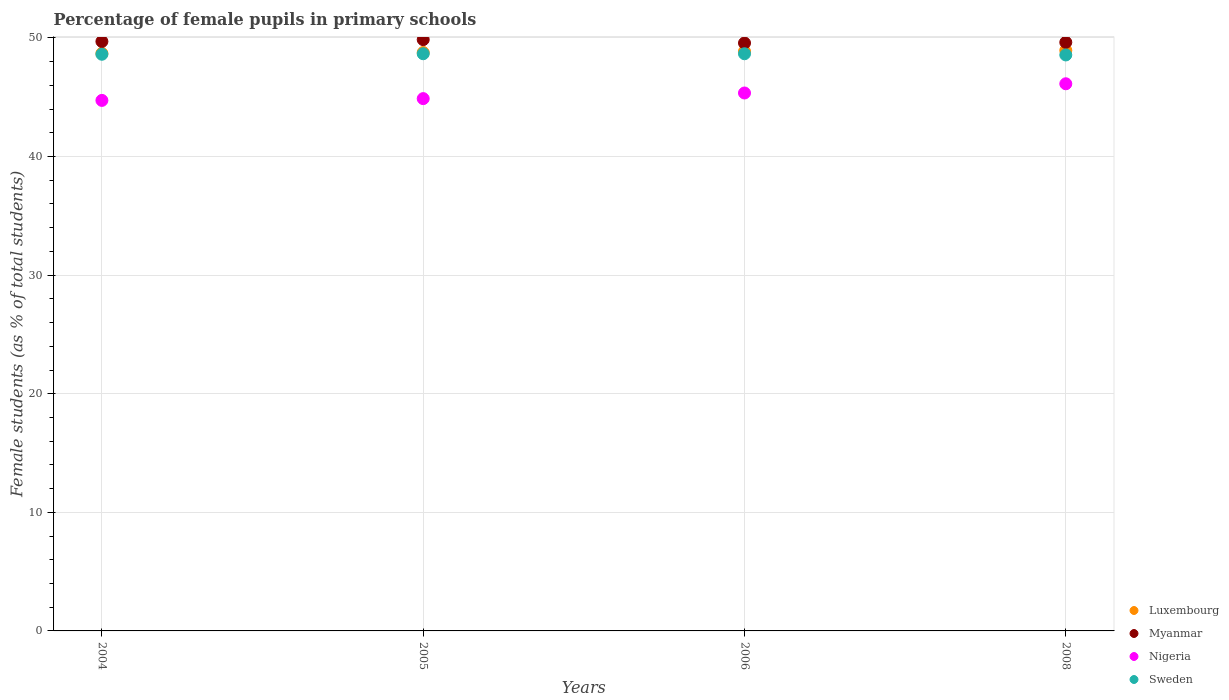Is the number of dotlines equal to the number of legend labels?
Offer a terse response. Yes. What is the percentage of female pupils in primary schools in Myanmar in 2008?
Offer a terse response. 49.63. Across all years, what is the maximum percentage of female pupils in primary schools in Luxembourg?
Keep it short and to the point. 48.95. Across all years, what is the minimum percentage of female pupils in primary schools in Nigeria?
Give a very brief answer. 44.73. In which year was the percentage of female pupils in primary schools in Myanmar maximum?
Provide a short and direct response. 2005. In which year was the percentage of female pupils in primary schools in Nigeria minimum?
Your answer should be compact. 2004. What is the total percentage of female pupils in primary schools in Luxembourg in the graph?
Offer a terse response. 195.29. What is the difference between the percentage of female pupils in primary schools in Luxembourg in 2005 and that in 2006?
Provide a succinct answer. -0.09. What is the difference between the percentage of female pupils in primary schools in Luxembourg in 2006 and the percentage of female pupils in primary schools in Myanmar in 2005?
Your answer should be compact. -0.99. What is the average percentage of female pupils in primary schools in Nigeria per year?
Make the answer very short. 45.28. In the year 2004, what is the difference between the percentage of female pupils in primary schools in Myanmar and percentage of female pupils in primary schools in Sweden?
Ensure brevity in your answer.  1.08. What is the ratio of the percentage of female pupils in primary schools in Sweden in 2006 to that in 2008?
Your answer should be very brief. 1. What is the difference between the highest and the second highest percentage of female pupils in primary schools in Nigeria?
Ensure brevity in your answer.  0.78. What is the difference between the highest and the lowest percentage of female pupils in primary schools in Nigeria?
Keep it short and to the point. 1.4. In how many years, is the percentage of female pupils in primary schools in Sweden greater than the average percentage of female pupils in primary schools in Sweden taken over all years?
Your answer should be very brief. 2. Is the sum of the percentage of female pupils in primary schools in Luxembourg in 2006 and 2008 greater than the maximum percentage of female pupils in primary schools in Myanmar across all years?
Your answer should be very brief. Yes. Is it the case that in every year, the sum of the percentage of female pupils in primary schools in Nigeria and percentage of female pupils in primary schools in Sweden  is greater than the percentage of female pupils in primary schools in Luxembourg?
Provide a succinct answer. Yes. Does the percentage of female pupils in primary schools in Myanmar monotonically increase over the years?
Make the answer very short. No. Is the percentage of female pupils in primary schools in Myanmar strictly greater than the percentage of female pupils in primary schools in Sweden over the years?
Provide a short and direct response. Yes. How many dotlines are there?
Keep it short and to the point. 4. Are the values on the major ticks of Y-axis written in scientific E-notation?
Make the answer very short. No. Does the graph contain any zero values?
Give a very brief answer. No. Does the graph contain grids?
Keep it short and to the point. Yes. What is the title of the graph?
Your response must be concise. Percentage of female pupils in primary schools. What is the label or title of the X-axis?
Keep it short and to the point. Years. What is the label or title of the Y-axis?
Ensure brevity in your answer.  Female students (as % of total students). What is the Female students (as % of total students) of Luxembourg in 2004?
Your answer should be compact. 48.7. What is the Female students (as % of total students) of Myanmar in 2004?
Provide a succinct answer. 49.7. What is the Female students (as % of total students) in Nigeria in 2004?
Offer a very short reply. 44.73. What is the Female students (as % of total students) of Sweden in 2004?
Offer a terse response. 48.63. What is the Female students (as % of total students) of Luxembourg in 2005?
Your response must be concise. 48.77. What is the Female students (as % of total students) of Myanmar in 2005?
Offer a terse response. 49.86. What is the Female students (as % of total students) in Nigeria in 2005?
Make the answer very short. 44.88. What is the Female students (as % of total students) of Sweden in 2005?
Provide a short and direct response. 48.67. What is the Female students (as % of total students) of Luxembourg in 2006?
Keep it short and to the point. 48.87. What is the Female students (as % of total students) of Myanmar in 2006?
Provide a succinct answer. 49.57. What is the Female students (as % of total students) of Nigeria in 2006?
Provide a short and direct response. 45.36. What is the Female students (as % of total students) of Sweden in 2006?
Offer a very short reply. 48.67. What is the Female students (as % of total students) in Luxembourg in 2008?
Provide a succinct answer. 48.95. What is the Female students (as % of total students) in Myanmar in 2008?
Provide a succinct answer. 49.63. What is the Female students (as % of total students) of Nigeria in 2008?
Your answer should be compact. 46.14. What is the Female students (as % of total students) in Sweden in 2008?
Ensure brevity in your answer.  48.57. Across all years, what is the maximum Female students (as % of total students) of Luxembourg?
Ensure brevity in your answer.  48.95. Across all years, what is the maximum Female students (as % of total students) of Myanmar?
Your answer should be compact. 49.86. Across all years, what is the maximum Female students (as % of total students) in Nigeria?
Keep it short and to the point. 46.14. Across all years, what is the maximum Female students (as % of total students) of Sweden?
Keep it short and to the point. 48.67. Across all years, what is the minimum Female students (as % of total students) in Luxembourg?
Make the answer very short. 48.7. Across all years, what is the minimum Female students (as % of total students) in Myanmar?
Offer a very short reply. 49.57. Across all years, what is the minimum Female students (as % of total students) of Nigeria?
Make the answer very short. 44.73. Across all years, what is the minimum Female students (as % of total students) in Sweden?
Give a very brief answer. 48.57. What is the total Female students (as % of total students) in Luxembourg in the graph?
Offer a very short reply. 195.29. What is the total Female students (as % of total students) in Myanmar in the graph?
Offer a terse response. 198.76. What is the total Female students (as % of total students) in Nigeria in the graph?
Make the answer very short. 181.11. What is the total Female students (as % of total students) in Sweden in the graph?
Keep it short and to the point. 194.53. What is the difference between the Female students (as % of total students) in Luxembourg in 2004 and that in 2005?
Provide a short and direct response. -0.07. What is the difference between the Female students (as % of total students) in Myanmar in 2004 and that in 2005?
Keep it short and to the point. -0.16. What is the difference between the Female students (as % of total students) in Nigeria in 2004 and that in 2005?
Keep it short and to the point. -0.15. What is the difference between the Female students (as % of total students) in Sweden in 2004 and that in 2005?
Make the answer very short. -0.04. What is the difference between the Female students (as % of total students) in Luxembourg in 2004 and that in 2006?
Give a very brief answer. -0.17. What is the difference between the Female students (as % of total students) in Myanmar in 2004 and that in 2006?
Your response must be concise. 0.13. What is the difference between the Female students (as % of total students) of Nigeria in 2004 and that in 2006?
Provide a short and direct response. -0.62. What is the difference between the Female students (as % of total students) in Sweden in 2004 and that in 2006?
Provide a succinct answer. -0.04. What is the difference between the Female students (as % of total students) of Luxembourg in 2004 and that in 2008?
Offer a very short reply. -0.26. What is the difference between the Female students (as % of total students) of Myanmar in 2004 and that in 2008?
Offer a terse response. 0.07. What is the difference between the Female students (as % of total students) of Nigeria in 2004 and that in 2008?
Ensure brevity in your answer.  -1.4. What is the difference between the Female students (as % of total students) of Sweden in 2004 and that in 2008?
Ensure brevity in your answer.  0.06. What is the difference between the Female students (as % of total students) of Luxembourg in 2005 and that in 2006?
Your answer should be very brief. -0.09. What is the difference between the Female students (as % of total students) in Myanmar in 2005 and that in 2006?
Provide a succinct answer. 0.29. What is the difference between the Female students (as % of total students) in Nigeria in 2005 and that in 2006?
Provide a succinct answer. -0.47. What is the difference between the Female students (as % of total students) of Sweden in 2005 and that in 2006?
Make the answer very short. 0. What is the difference between the Female students (as % of total students) in Luxembourg in 2005 and that in 2008?
Give a very brief answer. -0.18. What is the difference between the Female students (as % of total students) in Myanmar in 2005 and that in 2008?
Offer a terse response. 0.23. What is the difference between the Female students (as % of total students) of Nigeria in 2005 and that in 2008?
Your response must be concise. -1.25. What is the difference between the Female students (as % of total students) in Sweden in 2005 and that in 2008?
Offer a very short reply. 0.1. What is the difference between the Female students (as % of total students) of Luxembourg in 2006 and that in 2008?
Give a very brief answer. -0.09. What is the difference between the Female students (as % of total students) in Myanmar in 2006 and that in 2008?
Offer a terse response. -0.06. What is the difference between the Female students (as % of total students) in Nigeria in 2006 and that in 2008?
Your answer should be compact. -0.78. What is the difference between the Female students (as % of total students) of Sweden in 2006 and that in 2008?
Provide a short and direct response. 0.1. What is the difference between the Female students (as % of total students) of Luxembourg in 2004 and the Female students (as % of total students) of Myanmar in 2005?
Keep it short and to the point. -1.16. What is the difference between the Female students (as % of total students) in Luxembourg in 2004 and the Female students (as % of total students) in Nigeria in 2005?
Give a very brief answer. 3.81. What is the difference between the Female students (as % of total students) of Luxembourg in 2004 and the Female students (as % of total students) of Sweden in 2005?
Your answer should be very brief. 0.03. What is the difference between the Female students (as % of total students) of Myanmar in 2004 and the Female students (as % of total students) of Nigeria in 2005?
Your response must be concise. 4.82. What is the difference between the Female students (as % of total students) in Myanmar in 2004 and the Female students (as % of total students) in Sweden in 2005?
Provide a short and direct response. 1.03. What is the difference between the Female students (as % of total students) in Nigeria in 2004 and the Female students (as % of total students) in Sweden in 2005?
Keep it short and to the point. -3.94. What is the difference between the Female students (as % of total students) of Luxembourg in 2004 and the Female students (as % of total students) of Myanmar in 2006?
Give a very brief answer. -0.87. What is the difference between the Female students (as % of total students) of Luxembourg in 2004 and the Female students (as % of total students) of Nigeria in 2006?
Your response must be concise. 3.34. What is the difference between the Female students (as % of total students) of Luxembourg in 2004 and the Female students (as % of total students) of Sweden in 2006?
Ensure brevity in your answer.  0.03. What is the difference between the Female students (as % of total students) in Myanmar in 2004 and the Female students (as % of total students) in Nigeria in 2006?
Your response must be concise. 4.34. What is the difference between the Female students (as % of total students) of Myanmar in 2004 and the Female students (as % of total students) of Sweden in 2006?
Give a very brief answer. 1.04. What is the difference between the Female students (as % of total students) of Nigeria in 2004 and the Female students (as % of total students) of Sweden in 2006?
Offer a very short reply. -3.93. What is the difference between the Female students (as % of total students) of Luxembourg in 2004 and the Female students (as % of total students) of Myanmar in 2008?
Give a very brief answer. -0.93. What is the difference between the Female students (as % of total students) of Luxembourg in 2004 and the Female students (as % of total students) of Nigeria in 2008?
Offer a very short reply. 2.56. What is the difference between the Female students (as % of total students) in Luxembourg in 2004 and the Female students (as % of total students) in Sweden in 2008?
Provide a succinct answer. 0.13. What is the difference between the Female students (as % of total students) in Myanmar in 2004 and the Female students (as % of total students) in Nigeria in 2008?
Your answer should be very brief. 3.57. What is the difference between the Female students (as % of total students) of Myanmar in 2004 and the Female students (as % of total students) of Sweden in 2008?
Provide a short and direct response. 1.14. What is the difference between the Female students (as % of total students) in Nigeria in 2004 and the Female students (as % of total students) in Sweden in 2008?
Your response must be concise. -3.83. What is the difference between the Female students (as % of total students) of Luxembourg in 2005 and the Female students (as % of total students) of Myanmar in 2006?
Offer a very short reply. -0.8. What is the difference between the Female students (as % of total students) of Luxembourg in 2005 and the Female students (as % of total students) of Nigeria in 2006?
Offer a very short reply. 3.41. What is the difference between the Female students (as % of total students) of Luxembourg in 2005 and the Female students (as % of total students) of Sweden in 2006?
Make the answer very short. 0.1. What is the difference between the Female students (as % of total students) of Myanmar in 2005 and the Female students (as % of total students) of Nigeria in 2006?
Your answer should be very brief. 4.5. What is the difference between the Female students (as % of total students) in Myanmar in 2005 and the Female students (as % of total students) in Sweden in 2006?
Provide a short and direct response. 1.19. What is the difference between the Female students (as % of total students) of Nigeria in 2005 and the Female students (as % of total students) of Sweden in 2006?
Ensure brevity in your answer.  -3.78. What is the difference between the Female students (as % of total students) of Luxembourg in 2005 and the Female students (as % of total students) of Myanmar in 2008?
Provide a short and direct response. -0.86. What is the difference between the Female students (as % of total students) of Luxembourg in 2005 and the Female students (as % of total students) of Nigeria in 2008?
Your response must be concise. 2.64. What is the difference between the Female students (as % of total students) in Luxembourg in 2005 and the Female students (as % of total students) in Sweden in 2008?
Give a very brief answer. 0.21. What is the difference between the Female students (as % of total students) of Myanmar in 2005 and the Female students (as % of total students) of Nigeria in 2008?
Keep it short and to the point. 3.72. What is the difference between the Female students (as % of total students) in Myanmar in 2005 and the Female students (as % of total students) in Sweden in 2008?
Offer a very short reply. 1.29. What is the difference between the Female students (as % of total students) of Nigeria in 2005 and the Female students (as % of total students) of Sweden in 2008?
Your answer should be very brief. -3.68. What is the difference between the Female students (as % of total students) in Luxembourg in 2006 and the Female students (as % of total students) in Myanmar in 2008?
Give a very brief answer. -0.76. What is the difference between the Female students (as % of total students) of Luxembourg in 2006 and the Female students (as % of total students) of Nigeria in 2008?
Provide a short and direct response. 2.73. What is the difference between the Female students (as % of total students) of Luxembourg in 2006 and the Female students (as % of total students) of Sweden in 2008?
Offer a very short reply. 0.3. What is the difference between the Female students (as % of total students) in Myanmar in 2006 and the Female students (as % of total students) in Nigeria in 2008?
Provide a succinct answer. 3.44. What is the difference between the Female students (as % of total students) of Myanmar in 2006 and the Female students (as % of total students) of Sweden in 2008?
Your answer should be very brief. 1.01. What is the difference between the Female students (as % of total students) in Nigeria in 2006 and the Female students (as % of total students) in Sweden in 2008?
Give a very brief answer. -3.21. What is the average Female students (as % of total students) in Luxembourg per year?
Keep it short and to the point. 48.82. What is the average Female students (as % of total students) of Myanmar per year?
Provide a short and direct response. 49.69. What is the average Female students (as % of total students) of Nigeria per year?
Offer a very short reply. 45.28. What is the average Female students (as % of total students) of Sweden per year?
Provide a short and direct response. 48.63. In the year 2004, what is the difference between the Female students (as % of total students) of Luxembourg and Female students (as % of total students) of Myanmar?
Provide a short and direct response. -1. In the year 2004, what is the difference between the Female students (as % of total students) in Luxembourg and Female students (as % of total students) in Nigeria?
Provide a succinct answer. 3.96. In the year 2004, what is the difference between the Female students (as % of total students) in Luxembourg and Female students (as % of total students) in Sweden?
Provide a short and direct response. 0.07. In the year 2004, what is the difference between the Female students (as % of total students) of Myanmar and Female students (as % of total students) of Nigeria?
Offer a terse response. 4.97. In the year 2004, what is the difference between the Female students (as % of total students) in Myanmar and Female students (as % of total students) in Sweden?
Keep it short and to the point. 1.08. In the year 2004, what is the difference between the Female students (as % of total students) of Nigeria and Female students (as % of total students) of Sweden?
Ensure brevity in your answer.  -3.89. In the year 2005, what is the difference between the Female students (as % of total students) in Luxembourg and Female students (as % of total students) in Myanmar?
Give a very brief answer. -1.09. In the year 2005, what is the difference between the Female students (as % of total students) in Luxembourg and Female students (as % of total students) in Nigeria?
Give a very brief answer. 3.89. In the year 2005, what is the difference between the Female students (as % of total students) of Luxembourg and Female students (as % of total students) of Sweden?
Offer a very short reply. 0.1. In the year 2005, what is the difference between the Female students (as % of total students) in Myanmar and Female students (as % of total students) in Nigeria?
Ensure brevity in your answer.  4.98. In the year 2005, what is the difference between the Female students (as % of total students) in Myanmar and Female students (as % of total students) in Sweden?
Offer a terse response. 1.19. In the year 2005, what is the difference between the Female students (as % of total students) in Nigeria and Female students (as % of total students) in Sweden?
Provide a succinct answer. -3.78. In the year 2006, what is the difference between the Female students (as % of total students) in Luxembourg and Female students (as % of total students) in Myanmar?
Your response must be concise. -0.71. In the year 2006, what is the difference between the Female students (as % of total students) in Luxembourg and Female students (as % of total students) in Nigeria?
Your answer should be compact. 3.51. In the year 2006, what is the difference between the Female students (as % of total students) in Luxembourg and Female students (as % of total students) in Sweden?
Ensure brevity in your answer.  0.2. In the year 2006, what is the difference between the Female students (as % of total students) of Myanmar and Female students (as % of total students) of Nigeria?
Offer a terse response. 4.21. In the year 2006, what is the difference between the Female students (as % of total students) of Myanmar and Female students (as % of total students) of Sweden?
Your answer should be very brief. 0.91. In the year 2006, what is the difference between the Female students (as % of total students) in Nigeria and Female students (as % of total students) in Sweden?
Ensure brevity in your answer.  -3.31. In the year 2008, what is the difference between the Female students (as % of total students) in Luxembourg and Female students (as % of total students) in Myanmar?
Offer a very short reply. -0.68. In the year 2008, what is the difference between the Female students (as % of total students) of Luxembourg and Female students (as % of total students) of Nigeria?
Provide a succinct answer. 2.82. In the year 2008, what is the difference between the Female students (as % of total students) of Luxembourg and Female students (as % of total students) of Sweden?
Keep it short and to the point. 0.39. In the year 2008, what is the difference between the Female students (as % of total students) of Myanmar and Female students (as % of total students) of Nigeria?
Your answer should be compact. 3.49. In the year 2008, what is the difference between the Female students (as % of total students) of Myanmar and Female students (as % of total students) of Sweden?
Make the answer very short. 1.06. In the year 2008, what is the difference between the Female students (as % of total students) in Nigeria and Female students (as % of total students) in Sweden?
Your answer should be compact. -2.43. What is the ratio of the Female students (as % of total students) of Sweden in 2004 to that in 2005?
Make the answer very short. 1. What is the ratio of the Female students (as % of total students) of Nigeria in 2004 to that in 2006?
Ensure brevity in your answer.  0.99. What is the ratio of the Female students (as % of total students) of Luxembourg in 2004 to that in 2008?
Your answer should be compact. 0.99. What is the ratio of the Female students (as % of total students) in Myanmar in 2004 to that in 2008?
Provide a succinct answer. 1. What is the ratio of the Female students (as % of total students) in Nigeria in 2004 to that in 2008?
Offer a very short reply. 0.97. What is the ratio of the Female students (as % of total students) of Luxembourg in 2005 to that in 2006?
Your response must be concise. 1. What is the ratio of the Female students (as % of total students) in Nigeria in 2005 to that in 2006?
Keep it short and to the point. 0.99. What is the ratio of the Female students (as % of total students) in Sweden in 2005 to that in 2006?
Make the answer very short. 1. What is the ratio of the Female students (as % of total students) of Luxembourg in 2005 to that in 2008?
Your response must be concise. 1. What is the ratio of the Female students (as % of total students) in Myanmar in 2005 to that in 2008?
Give a very brief answer. 1. What is the ratio of the Female students (as % of total students) of Nigeria in 2005 to that in 2008?
Keep it short and to the point. 0.97. What is the ratio of the Female students (as % of total students) of Sweden in 2005 to that in 2008?
Your answer should be compact. 1. What is the ratio of the Female students (as % of total students) in Luxembourg in 2006 to that in 2008?
Your response must be concise. 1. What is the ratio of the Female students (as % of total students) of Myanmar in 2006 to that in 2008?
Offer a terse response. 1. What is the ratio of the Female students (as % of total students) of Nigeria in 2006 to that in 2008?
Give a very brief answer. 0.98. What is the difference between the highest and the second highest Female students (as % of total students) in Luxembourg?
Your response must be concise. 0.09. What is the difference between the highest and the second highest Female students (as % of total students) of Myanmar?
Keep it short and to the point. 0.16. What is the difference between the highest and the second highest Female students (as % of total students) in Nigeria?
Keep it short and to the point. 0.78. What is the difference between the highest and the second highest Female students (as % of total students) in Sweden?
Provide a short and direct response. 0. What is the difference between the highest and the lowest Female students (as % of total students) in Luxembourg?
Your response must be concise. 0.26. What is the difference between the highest and the lowest Female students (as % of total students) of Myanmar?
Ensure brevity in your answer.  0.29. What is the difference between the highest and the lowest Female students (as % of total students) in Nigeria?
Offer a terse response. 1.4. What is the difference between the highest and the lowest Female students (as % of total students) of Sweden?
Make the answer very short. 0.1. 